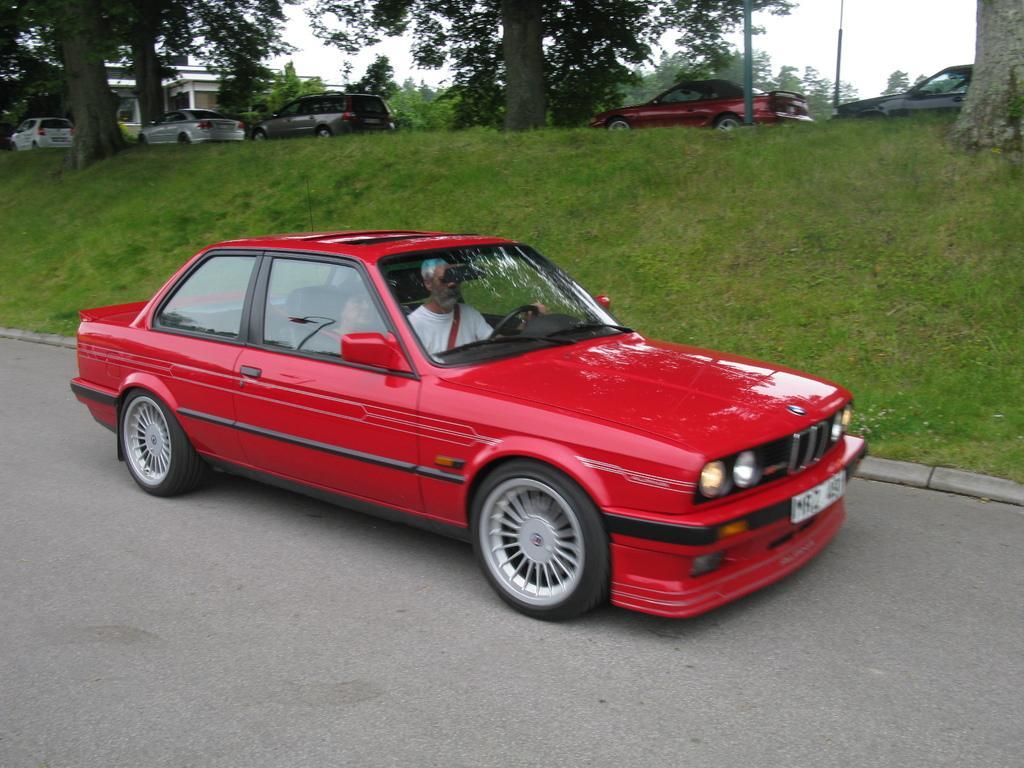Please provide a concise description of this image. In this image we can see two persons sitting in a car and we can also see grass, trees, vehicles and sky. 